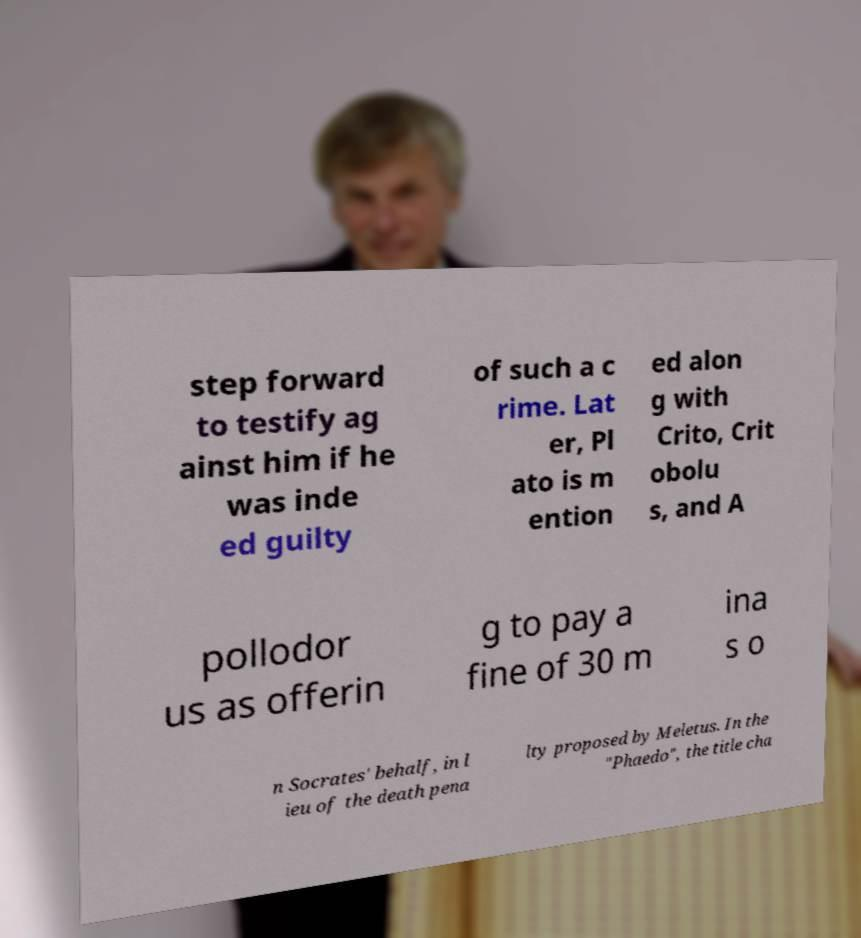Can you accurately transcribe the text from the provided image for me? step forward to testify ag ainst him if he was inde ed guilty of such a c rime. Lat er, Pl ato is m ention ed alon g with Crito, Crit obolu s, and A pollodor us as offerin g to pay a fine of 30 m ina s o n Socrates' behalf, in l ieu of the death pena lty proposed by Meletus. In the "Phaedo", the title cha 